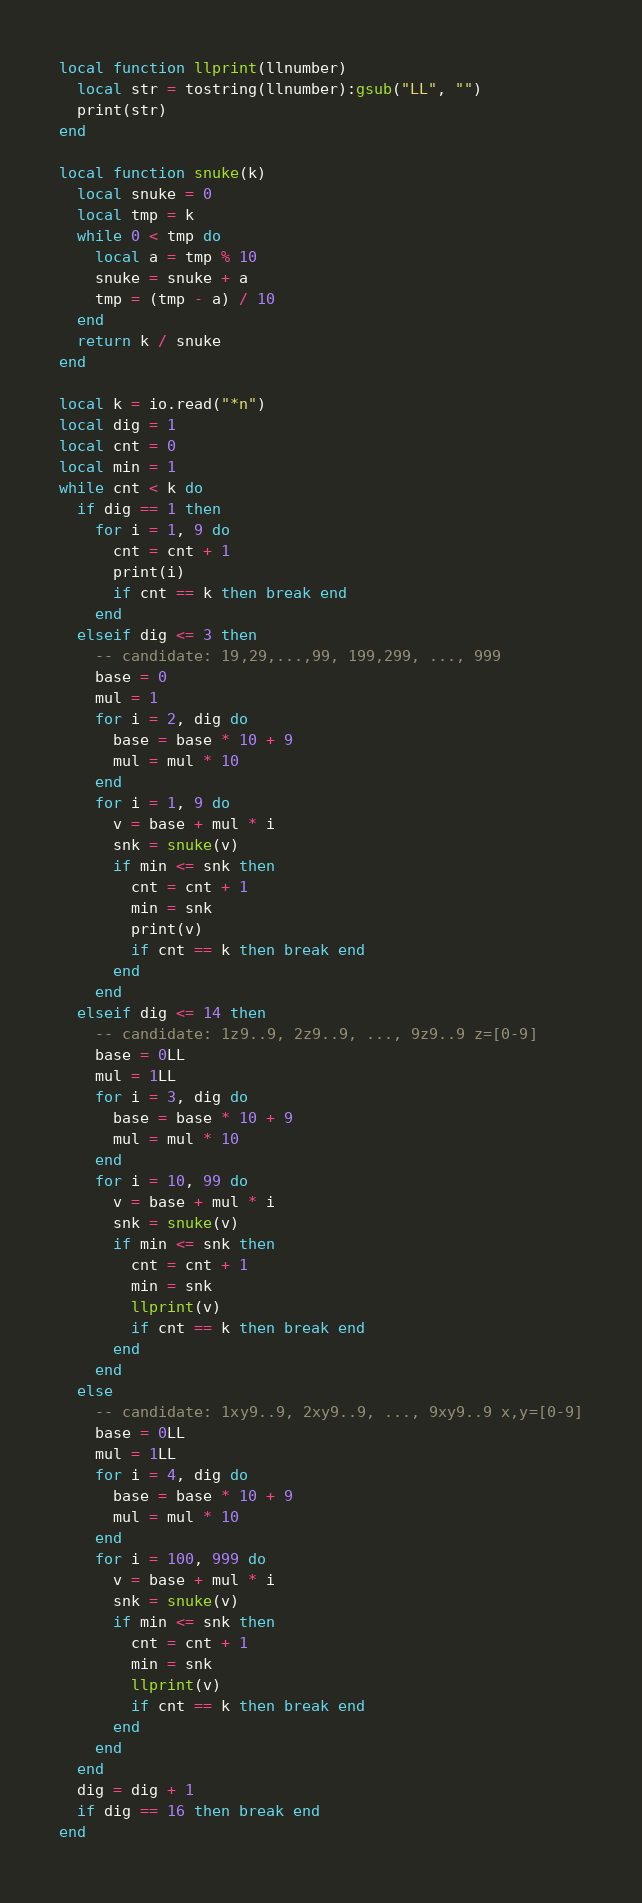Convert code to text. <code><loc_0><loc_0><loc_500><loc_500><_Lua_>local function llprint(llnumber)
  local str = tostring(llnumber):gsub("LL", "")
  print(str)
end

local function snuke(k)
  local snuke = 0
  local tmp = k
  while 0 < tmp do
    local a = tmp % 10
    snuke = snuke + a
    tmp = (tmp - a) / 10
  end
  return k / snuke
end

local k = io.read("*n")
local dig = 1
local cnt = 0
local min = 1
while cnt < k do
  if dig == 1 then
    for i = 1, 9 do
      cnt = cnt + 1
      print(i)
      if cnt == k then break end
    end
  elseif dig <= 3 then
    -- candidate: 19,29,...,99, 199,299, ..., 999
    base = 0
    mul = 1
    for i = 2, dig do
      base = base * 10 + 9
      mul = mul * 10
    end
    for i = 1, 9 do
      v = base + mul * i
      snk = snuke(v)
      if min <= snk then
        cnt = cnt + 1
        min = snk
        print(v)
        if cnt == k then break end
      end
    end
  elseif dig <= 14 then
    -- candidate: 1z9..9, 2z9..9, ..., 9z9..9 z=[0-9]
    base = 0LL
    mul = 1LL
    for i = 3, dig do
      base = base * 10 + 9
      mul = mul * 10
    end
    for i = 10, 99 do
      v = base + mul * i
      snk = snuke(v)
      if min <= snk then
        cnt = cnt + 1
        min = snk
        llprint(v)
        if cnt == k then break end
      end
    end
  else
    -- candidate: 1xy9..9, 2xy9..9, ..., 9xy9..9 x,y=[0-9]
    base = 0LL
    mul = 1LL
    for i = 4, dig do
      base = base * 10 + 9
      mul = mul * 10
    end
    for i = 100, 999 do
      v = base + mul * i
      snk = snuke(v)
      if min <= snk then
        cnt = cnt + 1
        min = snk
        llprint(v)
        if cnt == k then break end
      end
    end
  end
  dig = dig + 1
  if dig == 16 then break end
end
</code> 